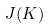<formula> <loc_0><loc_0><loc_500><loc_500>J ( K )</formula> 